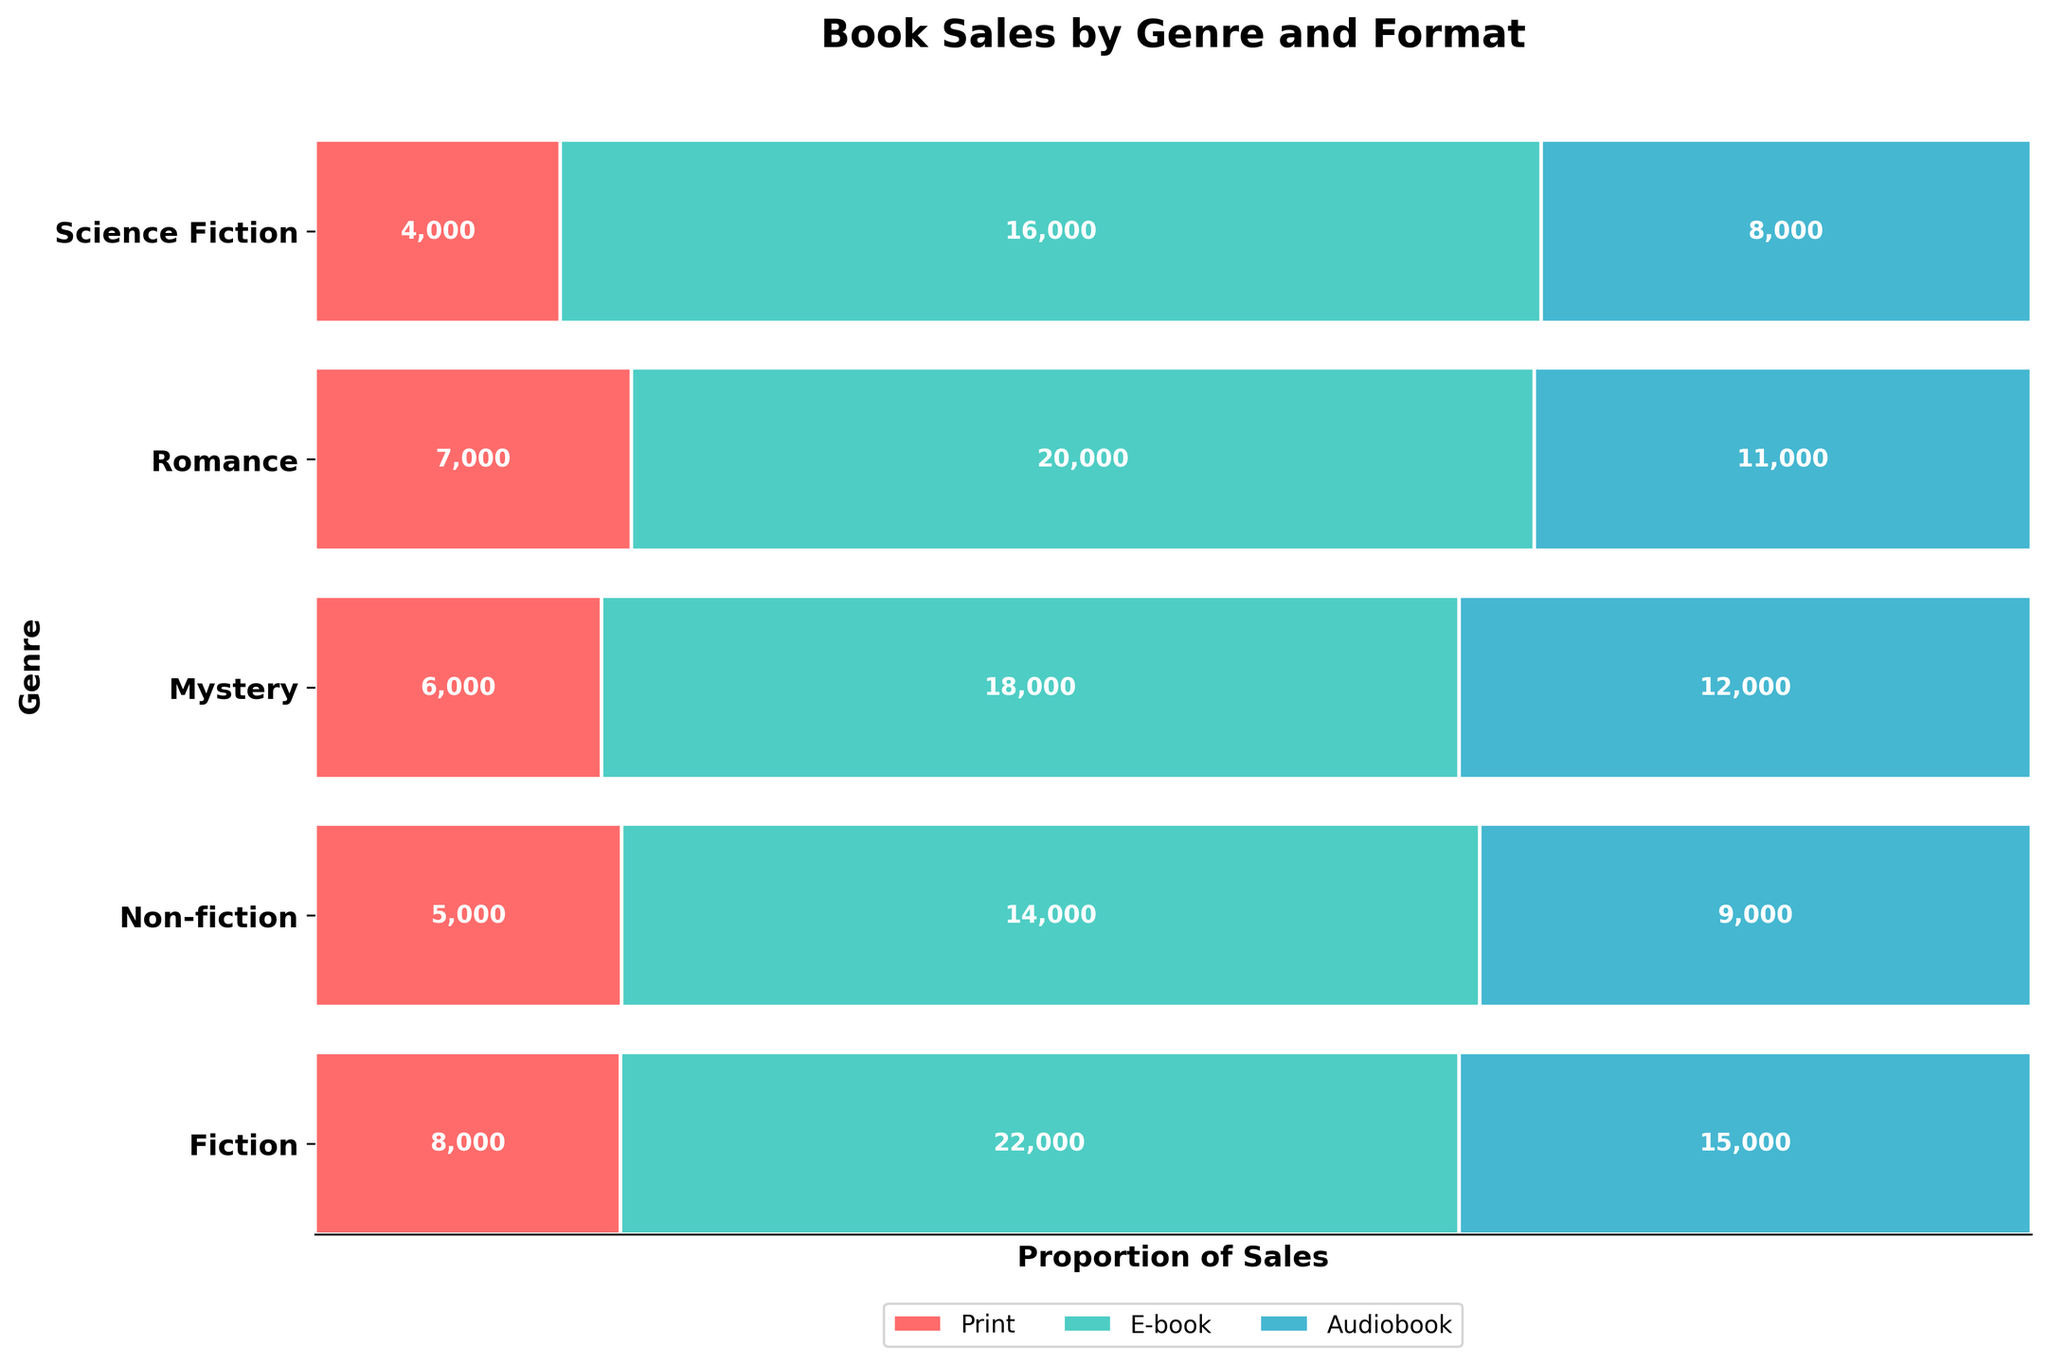What is the title of the plot? The plot title is usually found at the top of the plot. It provides a summary of what the plot is about.
Answer: Book Sales by Genre and Format Which genres have over 20,000 e-book sales? Look at the e-book sections of each genre and identify which sections, labeled with sales numbers, exceed 20,000.
Answer: Fiction, Romance Which genre has the highest total book sales? Sum the sales figures for each format (Print, E-book, Audiobook) for each genre. Compare the totals to determine the highest.
Answer: Fiction What is the proportion of Print sales to total sales for Non-fiction? Convert the Print sales of Non-fiction to a proportion of its total sales: Print sales / Total sales.
Answer: 0.3 Which format has the smallest sales in Science Fiction? Compare the sales figures for Print, E-book, and Audiobook within the Science Fiction genre. Identify the smallest number.
Answer: Audiobook Compare the sales of Audiobooks in Fiction and Mystery genres. Which genre has more sales? Look at the Audiobook sales figures for Fiction and Mystery genres. Compare these numbers.
Answer: Fiction By how much do E-book sales in Romance exceed those in Mystery? Calculate the difference between E-book sales in Romance and Mystery by subtracting Mystery's sales from Romance's sales.
Answer: 6,000 Which genre has the smallest proportion of Audiobook sales? Calculate the proportion of Audiobook sales to total sales for each genre and identify the smallest.
Answer: Science Fiction What colors are used to represent the formats in the plot? The legend at the bottom or side of the plot displays the colors used for each format.
Answer: Red, Teal, Cyan 